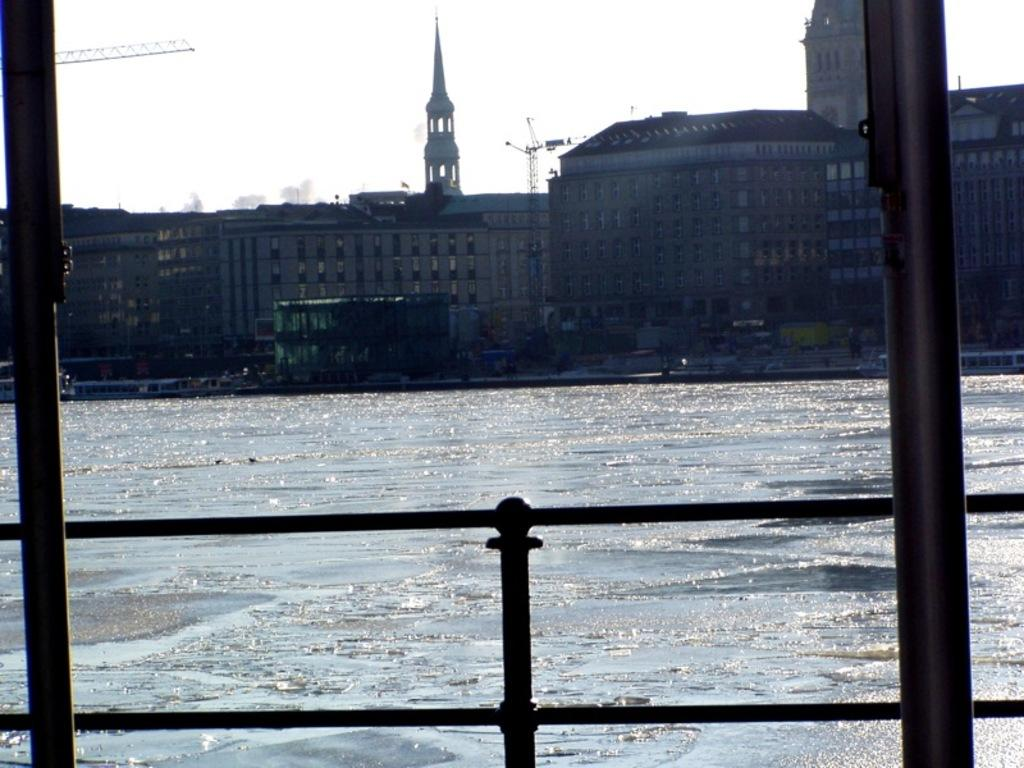What type of structure can be seen in the image? There is railing in the image. What other objects are present near the railing? There are poles in the image. What natural feature is visible behind the railing? A lake is visible behind the railing. What type of man-made structures are present behind the railing? Buildings are present behind the railing. What is visible at the top of the image? The sky is visible at the top of the image. How many ladybugs are crawling on the railing in the image? There are no ladybugs present in the image. What type of breakfast is being served on the poles in the image? There is no breakfast present in the image; it features railing, poles, a lake, buildings, and the sky. 